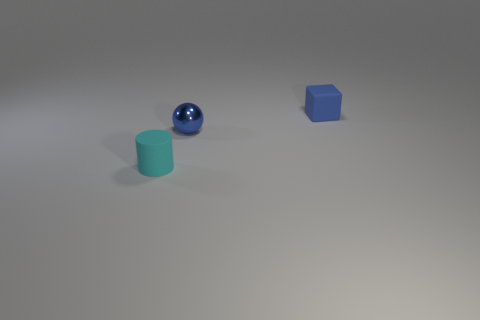Is the number of tiny gray metal things greater than the number of cylinders?
Your answer should be compact. No. How big is the cyan matte cylinder?
Your answer should be compact. Small. How many other things are there of the same color as the tiny cylinder?
Give a very brief answer. 0. Is the blue thing in front of the block made of the same material as the tiny cyan cylinder?
Your response must be concise. No. Are there fewer tiny blue shiny balls that are to the left of the tiny cyan object than tiny blue balls that are behind the shiny object?
Ensure brevity in your answer.  No. How many other things are there of the same material as the tiny cyan cylinder?
Your answer should be compact. 1. What material is the blue ball that is the same size as the cyan rubber thing?
Provide a succinct answer. Metal. Are there fewer cyan matte objects on the right side of the matte cube than gray objects?
Your answer should be very brief. No. What is the shape of the rubber object that is right of the small matte thing that is in front of the tiny rubber object that is behind the cyan cylinder?
Offer a terse response. Cube. There is a rubber object on the right side of the cylinder; how big is it?
Provide a succinct answer. Small. 